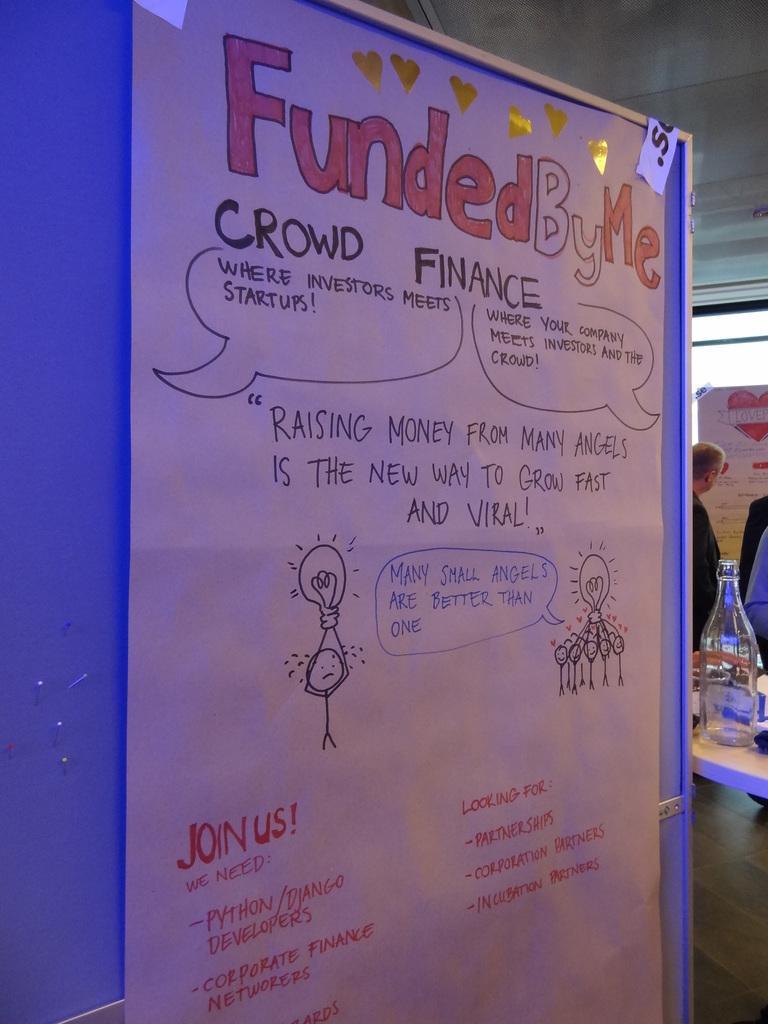Could you give a brief overview of what you see in this image? In the picture we can see a blue color board on it, we can see a magazine and behind it, we can see some person standing near the table with some items placed on it. 